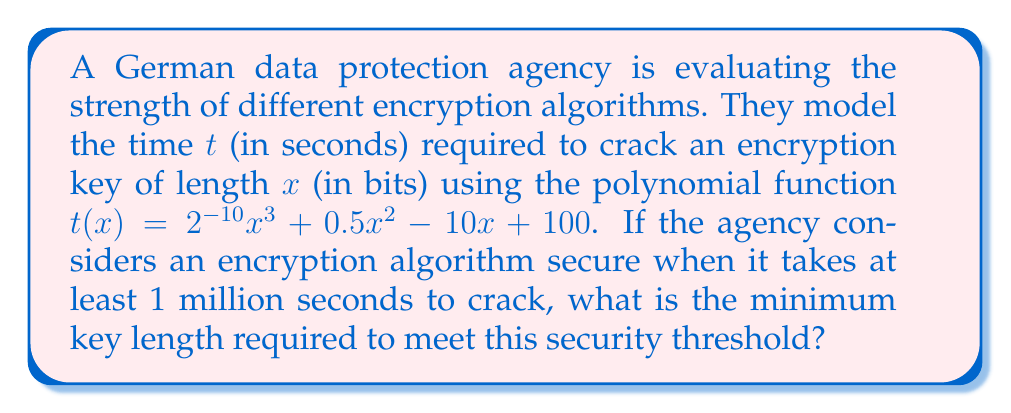Teach me how to tackle this problem. To solve this problem, we need to follow these steps:

1) We're looking for the value of $x$ where $t(x) = 1,000,000$ seconds. This can be represented as an equation:

   $$2^{-10}x^3 + 0.5x^2 - 10x + 100 = 1,000,000$$

2) Simplify by subtracting 100 from both sides:

   $$2^{-10}x^3 + 0.5x^2 - 10x = 999,900$$

3) This is a cubic equation and solving it analytically is complex. In practice, we would use numerical methods or graphing software to find the solution.

4) Using a graphing calculator or software, we can plot the function:

   $$y = 2^{-10}x^3 + 0.5x^2 - 10x - 999,900$$

   and find where it crosses the x-axis.

5) The solution is approximately $x \approx 126.8$ bits.

6) Since key length must be a whole number of bits, we round up to the nearest integer.

Therefore, the minimum key length required is 127 bits.
Answer: 127 bits 